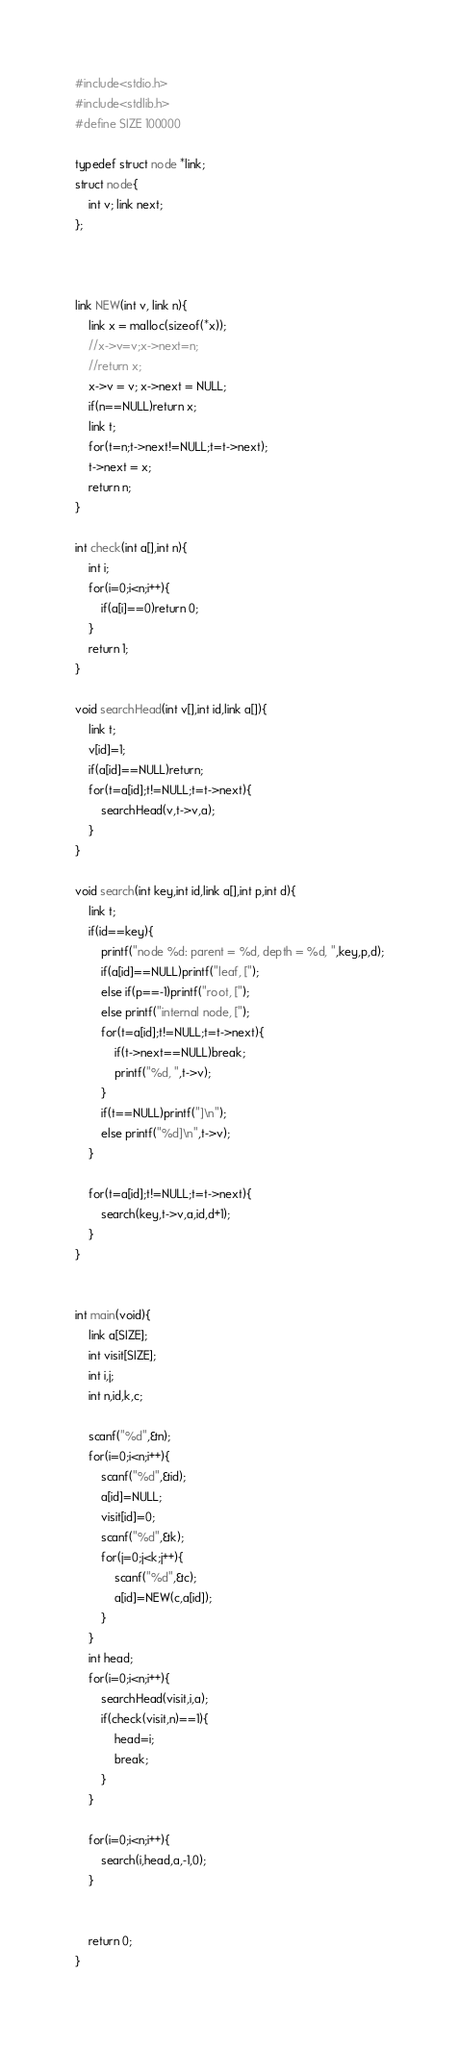<code> <loc_0><loc_0><loc_500><loc_500><_C_>#include<stdio.h>
#include<stdlib.h>
#define SIZE 100000

typedef struct node *link;
struct node{ 
	int v; link next; 
};



link NEW(int v, link n){ 
	link x = malloc(sizeof(*x));
	//x->v=v;x->next=n;
	//return x;
	x->v = v; x->next = NULL;
	if(n==NULL)return x;
	link t;
	for(t=n;t->next!=NULL;t=t->next);
	t->next = x;     
	return n;                         
}

int check(int a[],int n){
	int i;
	for(i=0;i<n;i++){
		if(a[i]==0)return 0;
	}
	return 1;
} 

void searchHead(int v[],int id,link a[]){
	link t;
	v[id]=1;
	if(a[id]==NULL)return;
	for(t=a[id];t!=NULL;t=t->next){
		searchHead(v,t->v,a);
	}
}

void search(int key,int id,link a[],int p,int d){
	link t;
	if(id==key){
		printf("node %d: parent = %d, depth = %d, ",key,p,d);
		if(a[id]==NULL)printf("leaf, [");
		else if(p==-1)printf("root, [");
		else printf("internal node, [");
		for(t=a[id];t!=NULL;t=t->next){
			if(t->next==NULL)break;
			printf("%d, ",t->v);
		}
		if(t==NULL)printf("]\n");
		else printf("%d]\n",t->v);
	}
	
	for(t=a[id];t!=NULL;t=t->next){
		search(key,t->v,a,id,d+1);
	}
}


int main(void){
	link a[SIZE];
	int visit[SIZE];
	int i,j;
	int n,id,k,c;
	
	scanf("%d",&n);
	for(i=0;i<n;i++){
		scanf("%d",&id);
		a[id]=NULL;
		visit[id]=0;
		scanf("%d",&k);
		for(j=0;j<k;j++){
			scanf("%d",&c);
			a[id]=NEW(c,a[id]);
		}
	}
	int head;
	for(i=0;i<n;i++){
		searchHead(visit,i,a);
		if(check(visit,n)==1){
			head=i;
			break;
		}
	}
	
	for(i=0;i<n;i++){
		search(i,head,a,-1,0);
	}
	
	
	return 0;
}</code> 